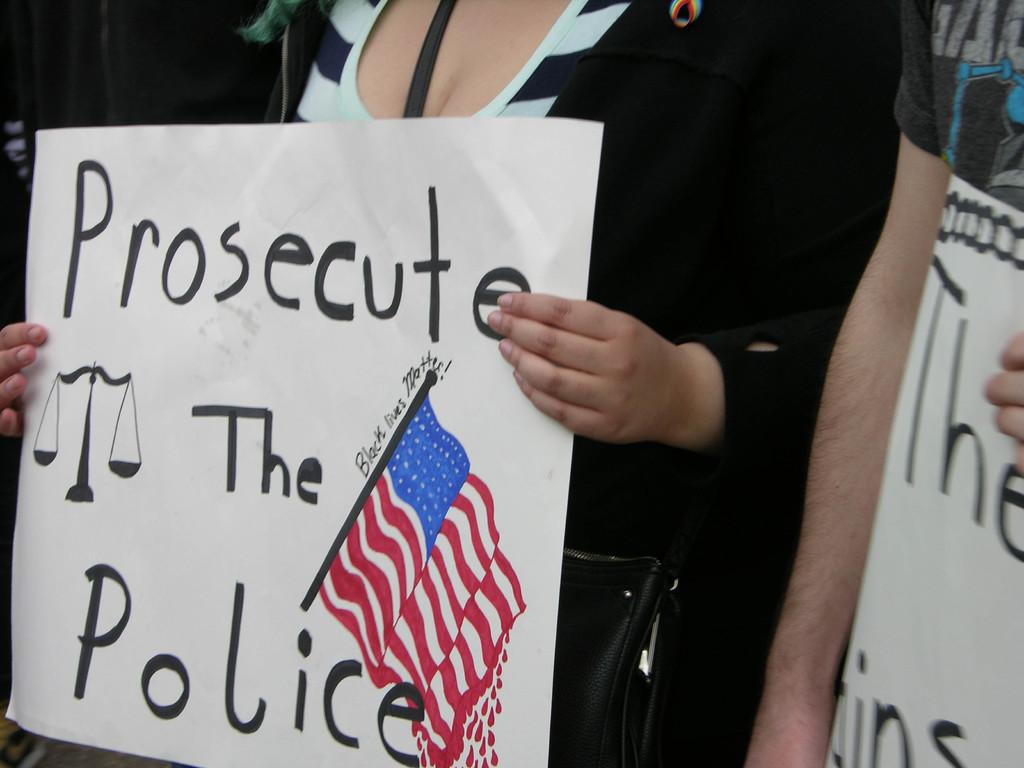<image>
Offer a succinct explanation of the picture presented. a white sign that has the word prosecute on it 